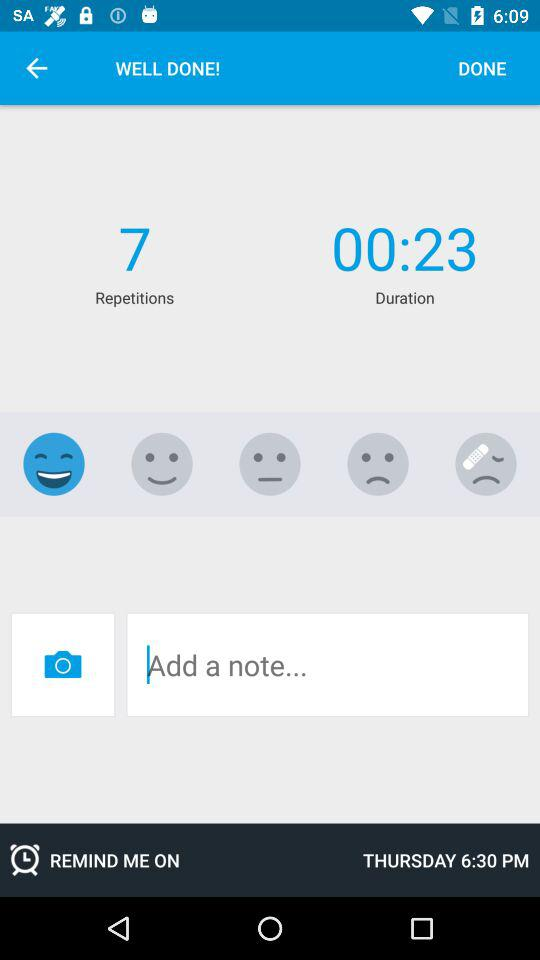How many faces are showing a negative emotion?
Answer the question using a single word or phrase. 3 